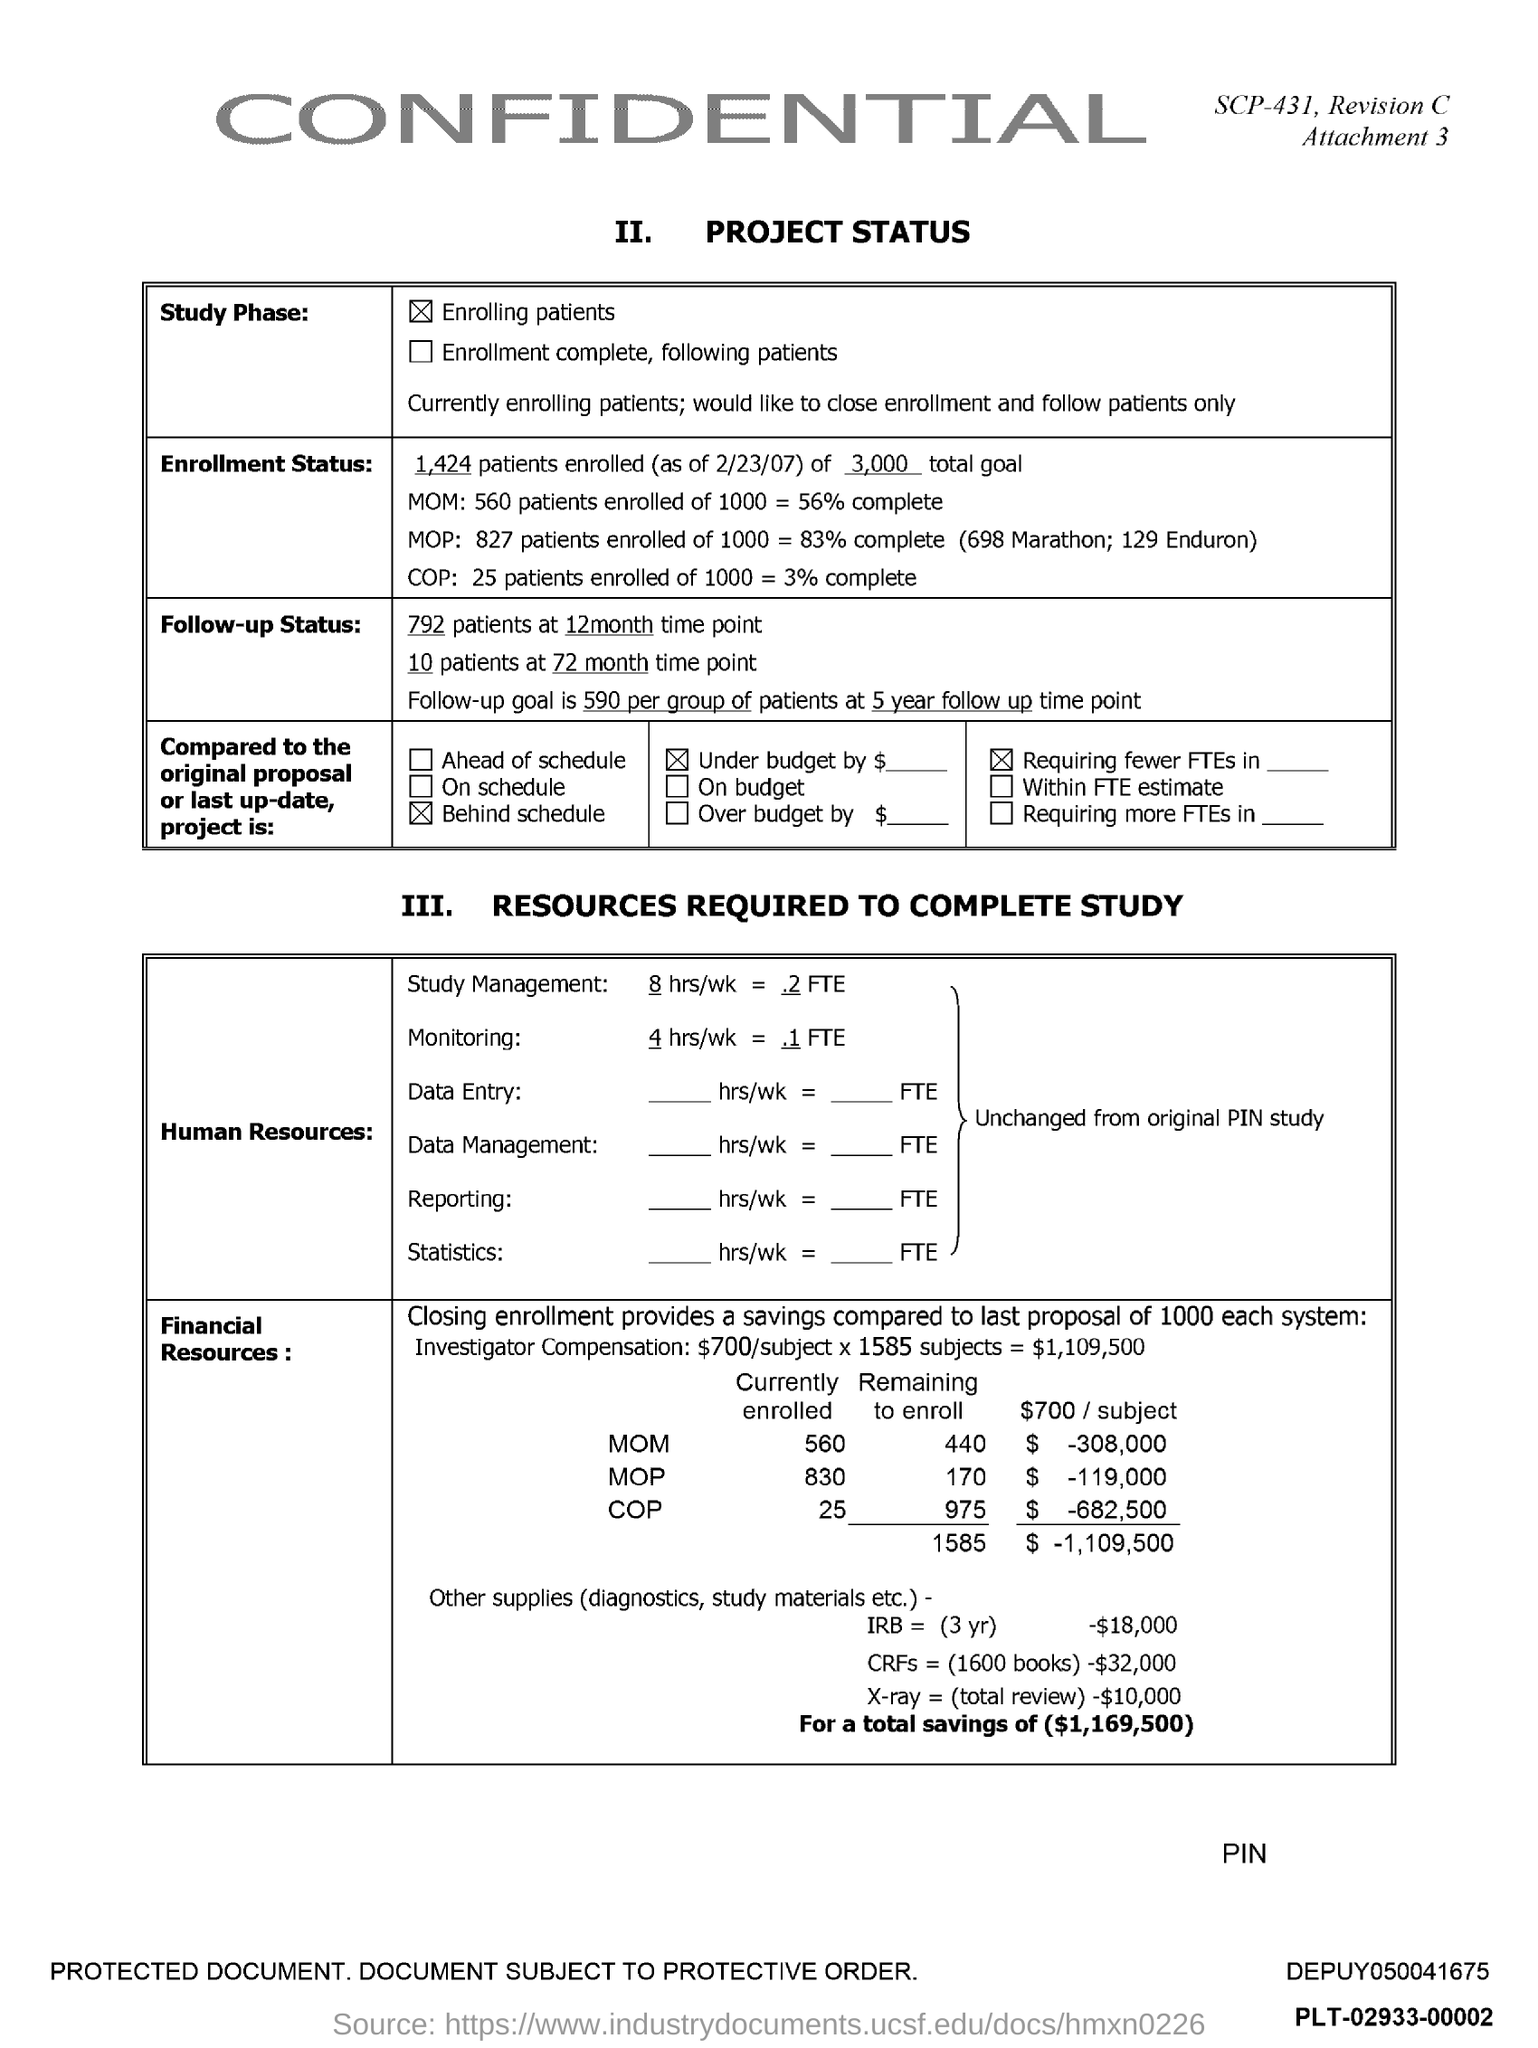Indicate a few pertinent items in this graphic. The attachment number mentioned in the document is 3. 